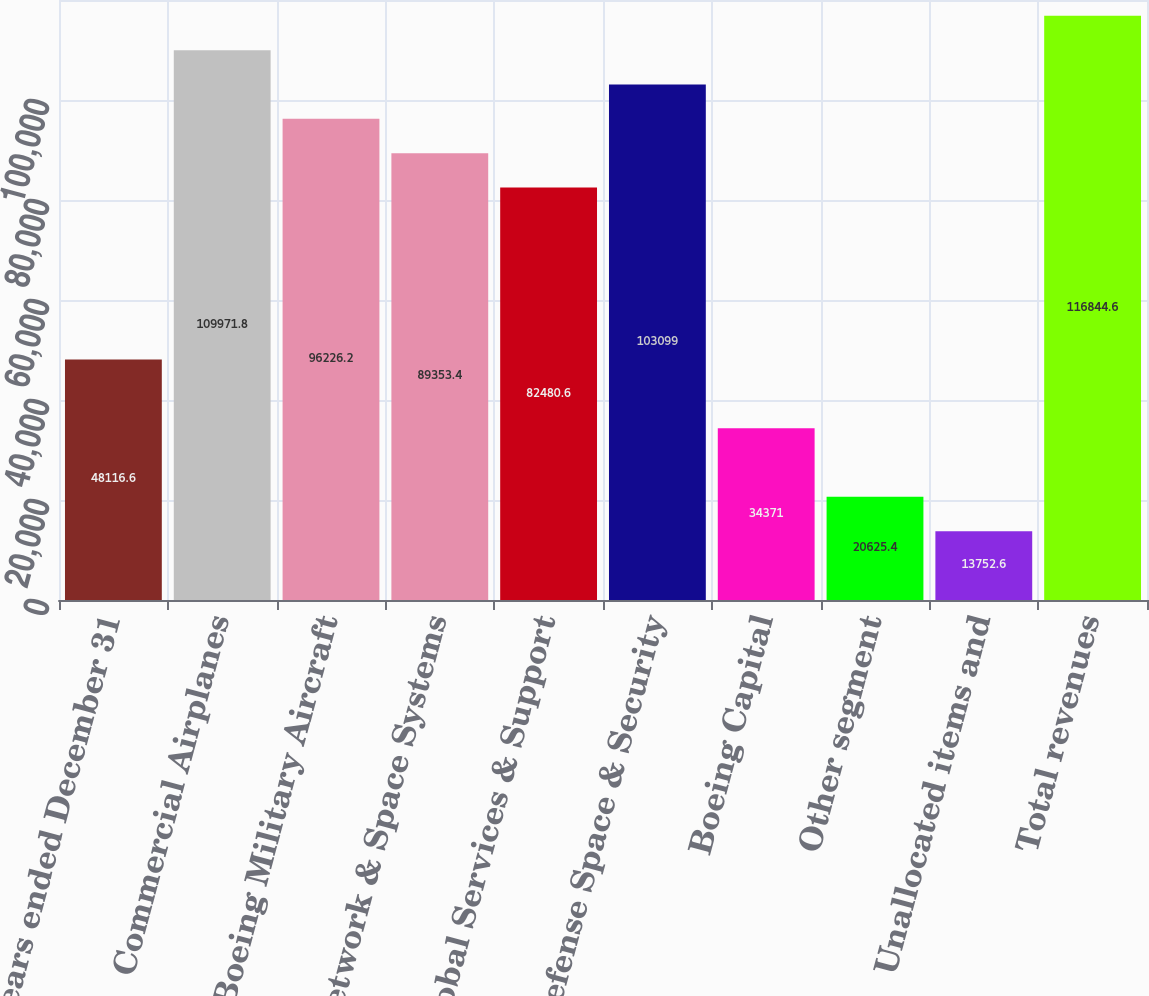Convert chart to OTSL. <chart><loc_0><loc_0><loc_500><loc_500><bar_chart><fcel>Years ended December 31<fcel>Commercial Airplanes<fcel>Boeing Military Aircraft<fcel>Network & Space Systems<fcel>Global Services & Support<fcel>Total Defense Space & Security<fcel>Boeing Capital<fcel>Other segment<fcel>Unallocated items and<fcel>Total revenues<nl><fcel>48116.6<fcel>109972<fcel>96226.2<fcel>89353.4<fcel>82480.6<fcel>103099<fcel>34371<fcel>20625.4<fcel>13752.6<fcel>116845<nl></chart> 